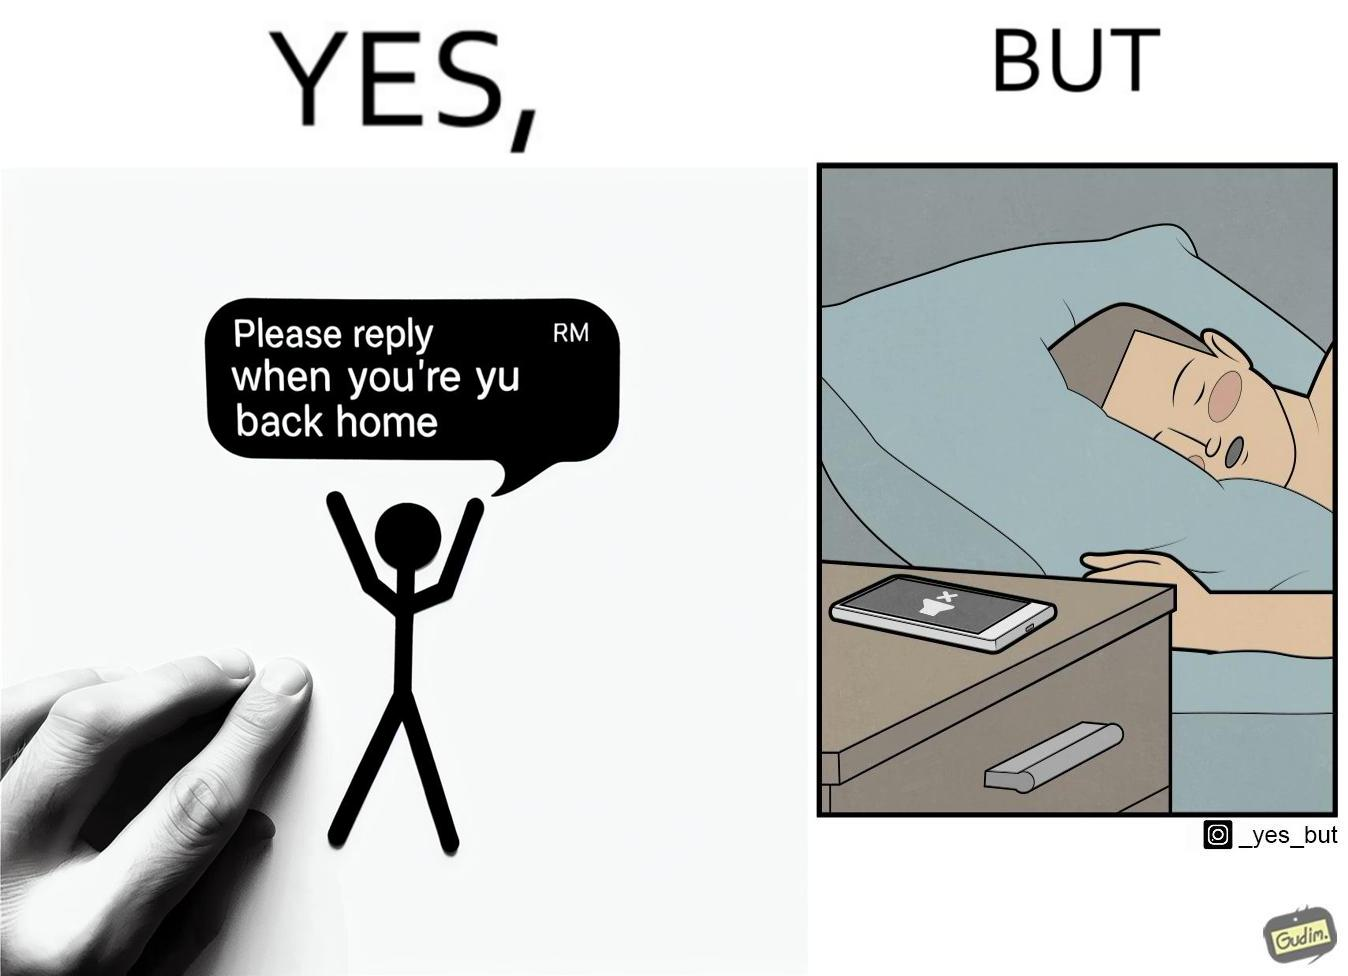Provide a description of this image. The images are funny since they show how a sender wants the recipient to revert once he gets back home but the tired recipient ends up falling asleep completely forgetting about the message while the sender keeps waiting for a reply. The fact that the recipient leaves his phone on silent mode makes it even funnier since the probability of the sender being able to contact him becomes even slimmer. 